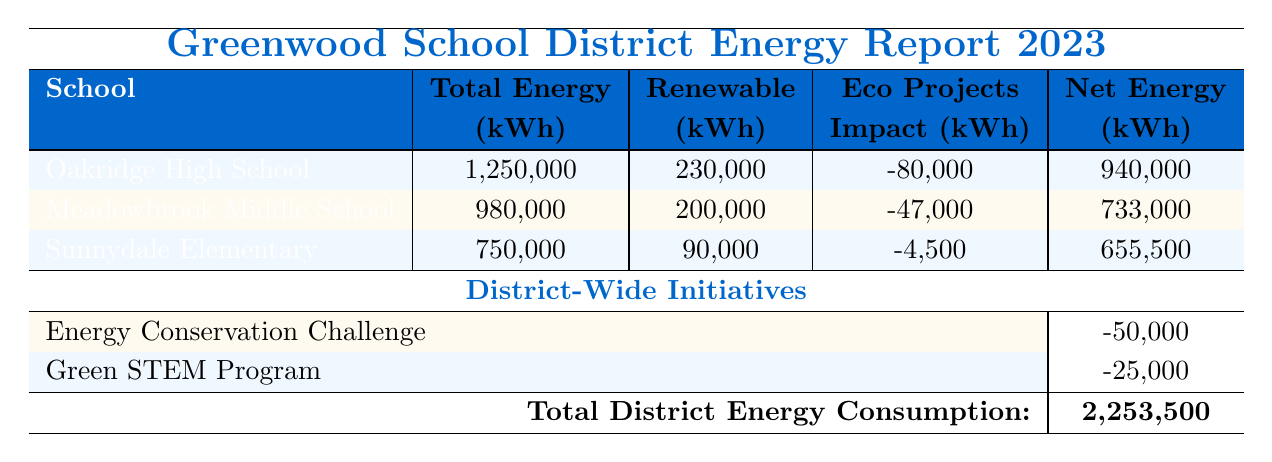What is the total energy consumption of Oakridge High School? According to the table, Oakridge High School has a total energy consumption listed as 1,250,000 kWh.
Answer: 1,250,000 kWh How much renewable energy did Meadowbrook Middle School generate? The table states that Meadowbrook Middle School generated 200,000 kWh of renewable energy.
Answer: 200,000 kWh Which school had the largest net energy consumption after accounting for eco projects? The net energy for each school can be calculated by subtracting their eco project impacts from their total energy consumption. Oakridge HS: 1,250,000 - 80,000 = 940,000; Meadowbrook MS: 980,000 - 47,000 = 733,000; Sunnydale ES: 750,000 - 4,500 = 655,500. Oakridge has the largest net energy consumption of 940,000 kWh.
Answer: Oakridge High School What is the total impact of eco projects across all schools? The eco project impacts are: Oakridge (-80,000), Meadowbrook (-47,000), and Sunnydale (-4,500). Adding them together results in -80,000 - 47,000 - 4,500 = -131,500 kWh in total impact.
Answer: -131,500 kWh Did Sunnydale Elementary use any renewable energy sources besides solar? The table indicates that Sunnydale Elementary only mentions solar as its renewable energy source, with 90,000 kWh. Thus, it did not use any other renewable energy sources.
Answer: No What is the average amount of renewable energy contributed by the three schools? The total renewable energy contributions are: Oakridge (230,000), Meadowbrook (200,000), Sunnydale (90,000). The sum is 230,000 + 200,000 + 90,000 = 520,000 kWh. With three schools, the average is 520,000 / 3 = 173,333.33 kWh.
Answer: 173,333.33 kWh How much energy would the district save if both district-wide initiatives are implemented? The total impact of district-wide initiatives from the table is the sum of the average impacts: -50,000 (Energy Conservation Challenge) + -25,000 (Green STEM Program) = -75,000 kWh.
Answer: -75,000 kWh Which school has the least total energy consumption? Comparing the total energy consumptions: Oakridge (1,250,000 kWh), Meadowbrook (980,000 kWh), and Sunnydale (750,000 kWh), Sunnydale has the least total consumption of 750,000 kWh.
Answer: Sunnydale Elementary What would be the total net energy consumption of the district if all eco projects and initiatives are considered? The total consumption is affected by the total energy consumption of each school and the impacts of the eco projects and district initiatives. Total district energy consumption is 2,253,500 kWh (given in the table), and the total eco project impact is -131,500 kWh, while the initiatives add an impact of -75,000 kWh. Therefore, the final total would be 2,253,500 - 131,500 - 75,000 = 2,047,000 kWh.
Answer: 2,047,000 kWh Which school had the smallest impact from eco projects per unit of total energy consumed? First, we calculate the eco project impact per kWh for each school: Oakridge: -80,000 kWh / 1,250,000 kWh = -0.064; Meadowbrook: -47,000 kWh / 980,000 kWh = -0.048; Sunnydale: -4,500 kWh / 750,000 kWh = -0.006. Sunnydale has the smallest impact per unit of energy consumed.
Answer: Sunnydale Elementary 